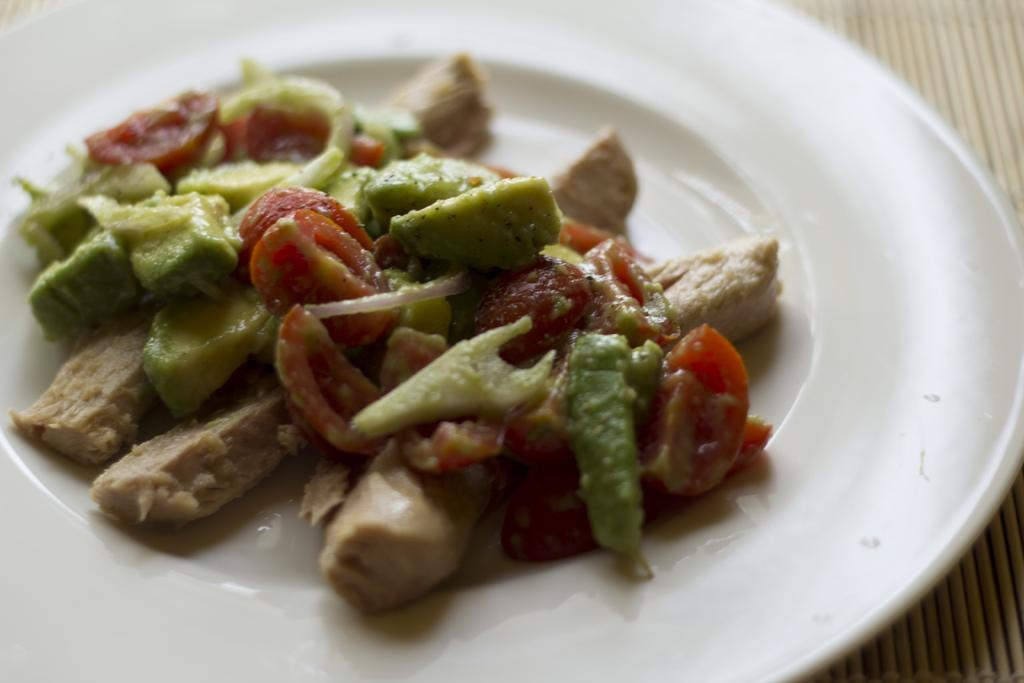What is on the plate that is visible in the image? There is a white plate in the image. What is on top of the plate? There is food on the plate. What colors can be seen in the food on the plate? The food has green, brown, and red colors. How does the father contribute to the food preparation in the image? There is no father present in the image, and no information about food preparation is provided. 